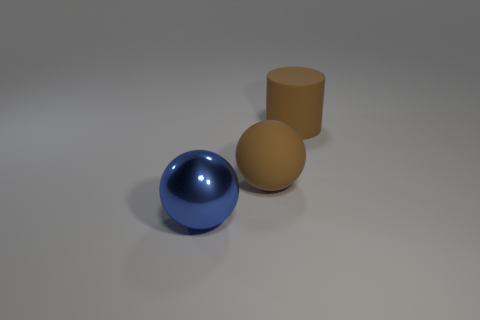Add 1 large matte cylinders. How many objects exist? 4 Subtract all spheres. How many objects are left? 1 Add 2 big brown spheres. How many big brown spheres are left? 3 Add 1 big brown spheres. How many big brown spheres exist? 2 Subtract 0 red spheres. How many objects are left? 3 Subtract all brown matte objects. Subtract all large matte balls. How many objects are left? 0 